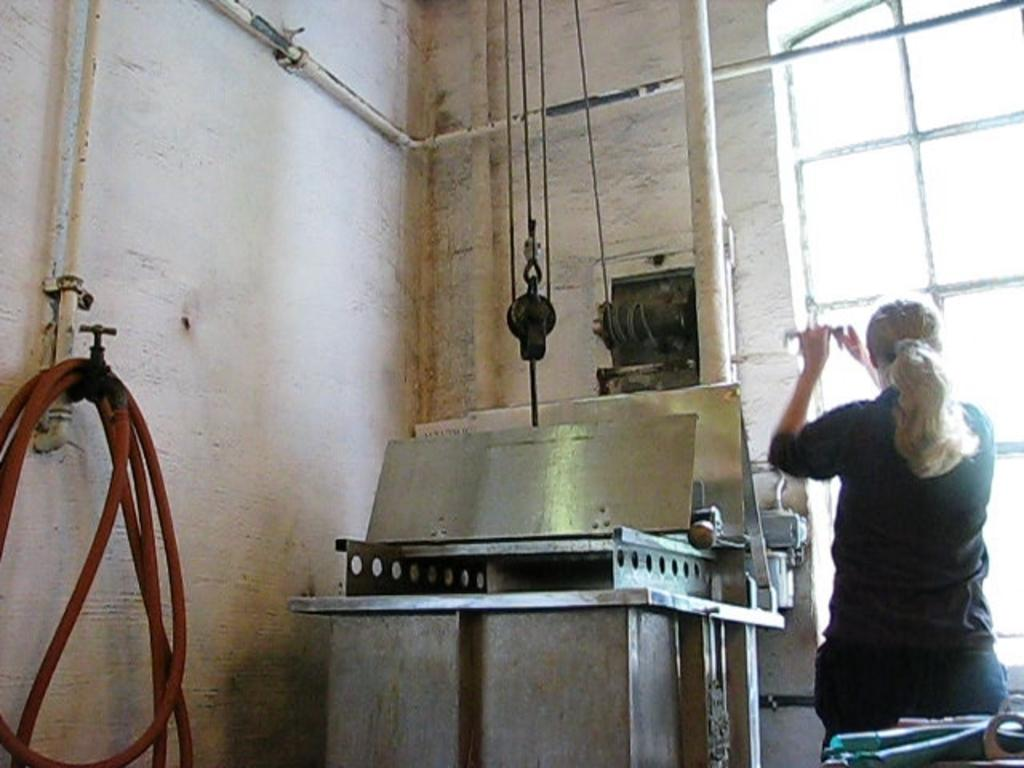What is the setting of the image? The image shows an inner view of a room. What is the woman in the image doing? The woman is operating a machine in the room. Is there any source of natural light in the room? Yes, there is a window in the room. What is the woman wearing? The woman is wearing a black color dress. Can you describe any plumbing fixtures in the room? Yes, there is a tap with a pipe in the room. What type of trousers is the woman wearing in the image? The image does not show the woman wearing any trousers; she is wearing a dress. What color is the knife on the table in the image? There is no knife present in the image. 